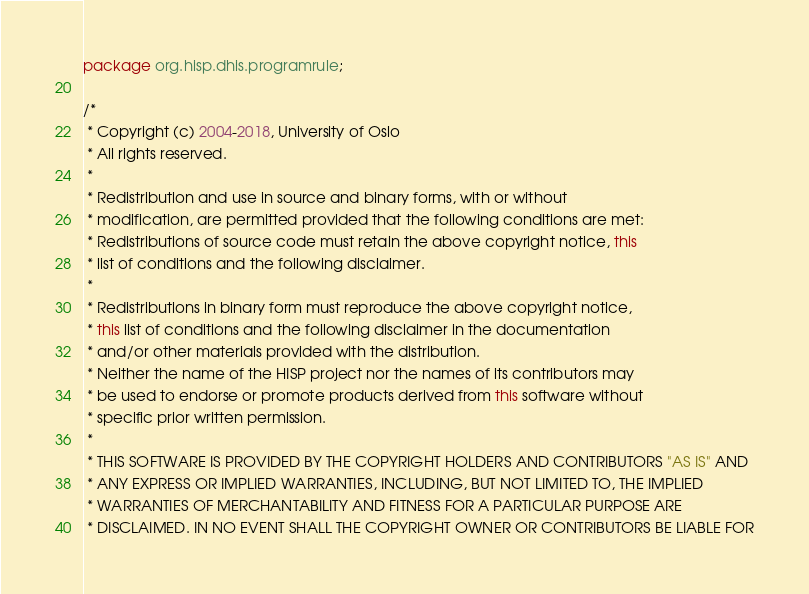<code> <loc_0><loc_0><loc_500><loc_500><_Java_>package org.hisp.dhis.programrule;

/*
 * Copyright (c) 2004-2018, University of Oslo
 * All rights reserved.
 *
 * Redistribution and use in source and binary forms, with or without
 * modification, are permitted provided that the following conditions are met:
 * Redistributions of source code must retain the above copyright notice, this
 * list of conditions and the following disclaimer.
 *
 * Redistributions in binary form must reproduce the above copyright notice,
 * this list of conditions and the following disclaimer in the documentation
 * and/or other materials provided with the distribution.
 * Neither the name of the HISP project nor the names of its contributors may
 * be used to endorse or promote products derived from this software without
 * specific prior written permission.
 *
 * THIS SOFTWARE IS PROVIDED BY THE COPYRIGHT HOLDERS AND CONTRIBUTORS "AS IS" AND
 * ANY EXPRESS OR IMPLIED WARRANTIES, INCLUDING, BUT NOT LIMITED TO, THE IMPLIED
 * WARRANTIES OF MERCHANTABILITY AND FITNESS FOR A PARTICULAR PURPOSE ARE
 * DISCLAIMED. IN NO EVENT SHALL THE COPYRIGHT OWNER OR CONTRIBUTORS BE LIABLE FOR</code> 